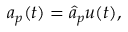<formula> <loc_0><loc_0><loc_500><loc_500>\begin{array} { r } { a _ { p } ( t ) = \hat { a } _ { p } u ( t ) , } \end{array}</formula> 